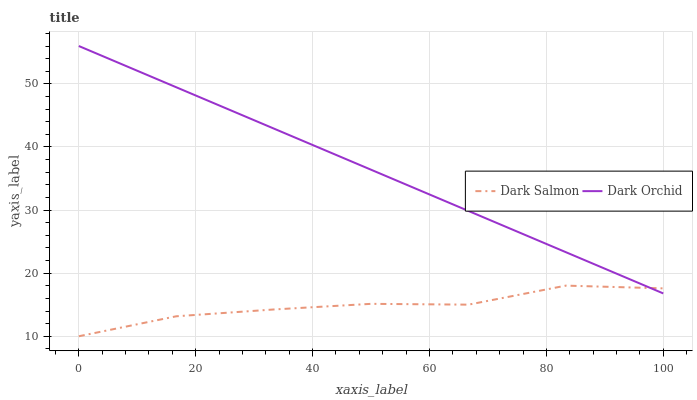Does Dark Orchid have the minimum area under the curve?
Answer yes or no. No. Is Dark Orchid the roughest?
Answer yes or no. No. Does Dark Orchid have the lowest value?
Answer yes or no. No. 